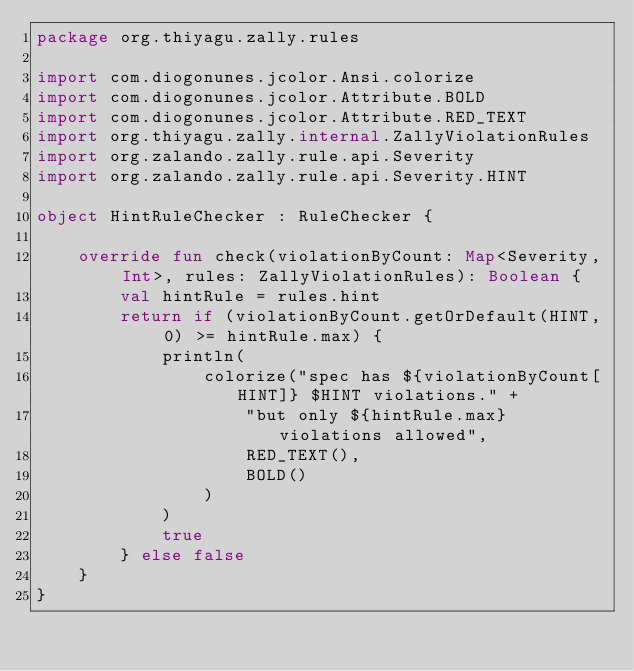<code> <loc_0><loc_0><loc_500><loc_500><_Kotlin_>package org.thiyagu.zally.rules

import com.diogonunes.jcolor.Ansi.colorize
import com.diogonunes.jcolor.Attribute.BOLD
import com.diogonunes.jcolor.Attribute.RED_TEXT
import org.thiyagu.zally.internal.ZallyViolationRules
import org.zalando.zally.rule.api.Severity
import org.zalando.zally.rule.api.Severity.HINT

object HintRuleChecker : RuleChecker {

    override fun check(violationByCount: Map<Severity, Int>, rules: ZallyViolationRules): Boolean {
        val hintRule = rules.hint
        return if (violationByCount.getOrDefault(HINT, 0) >= hintRule.max) {
            println(
                colorize("spec has ${violationByCount[HINT]} $HINT violations." +
                    "but only ${hintRule.max} violations allowed",
                    RED_TEXT(),
                    BOLD()
                )
            )
            true
        } else false
    }
}
</code> 